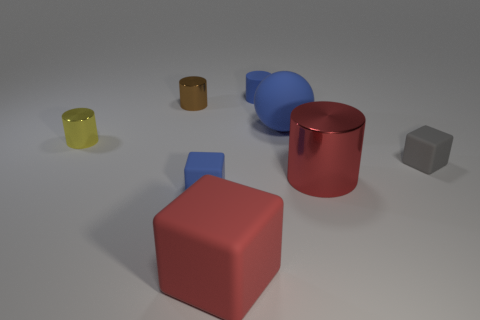Subtract 1 cylinders. How many cylinders are left? 3 Add 1 small yellow cylinders. How many objects exist? 9 Subtract all balls. How many objects are left? 7 Subtract 0 red balls. How many objects are left? 8 Subtract all metallic balls. Subtract all yellow metal things. How many objects are left? 7 Add 4 blue balls. How many blue balls are left? 5 Add 3 large red matte objects. How many large red matte objects exist? 4 